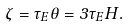<formula> <loc_0><loc_0><loc_500><loc_500>\zeta = \tau _ { E } \theta = 3 \tau _ { E } H .</formula> 